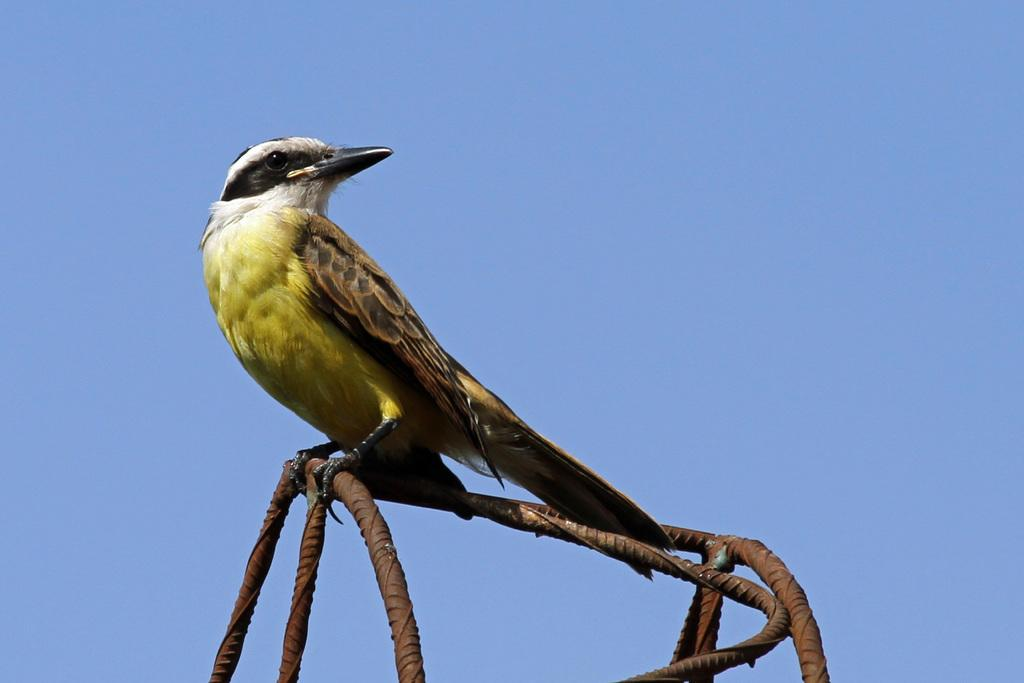Where was the picture taken? The picture was clicked outside the city. What is the main subject of the image? There is a bird in the center of the image. What color is the bird's beak? The bird has a black color beak. What is the bird standing on? The bird is standing on a metal object. What can be seen in the background of the image? There is a sky visible in the background of the image. What is the bird's chance of winning a tooth in the image? There is no mention of a tooth or any competition in the image, so it's not possible to determine the bird's chance of winning one. 